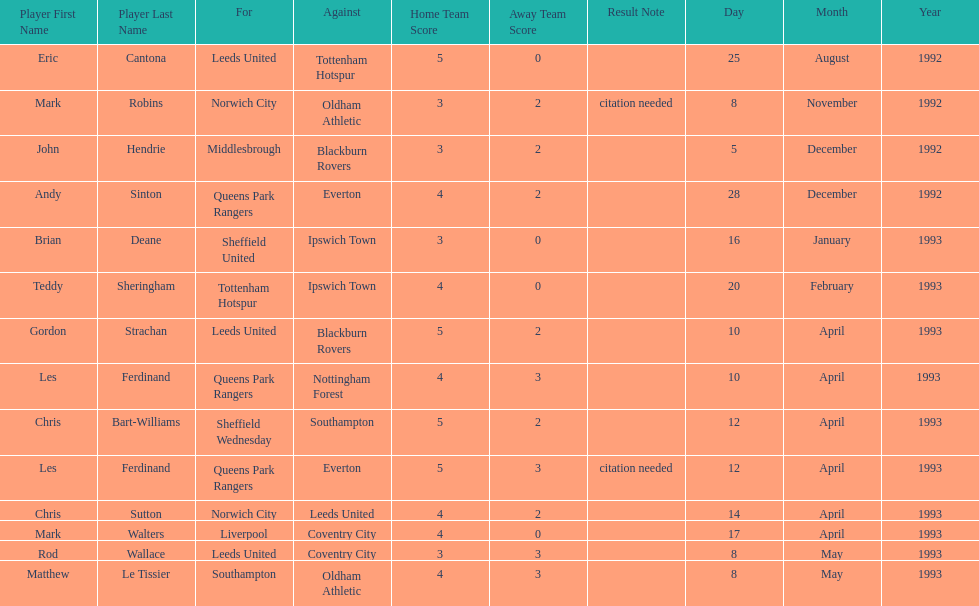In the 1992-1993 premier league, what was the total number of hat tricks scored by all players? 14. 